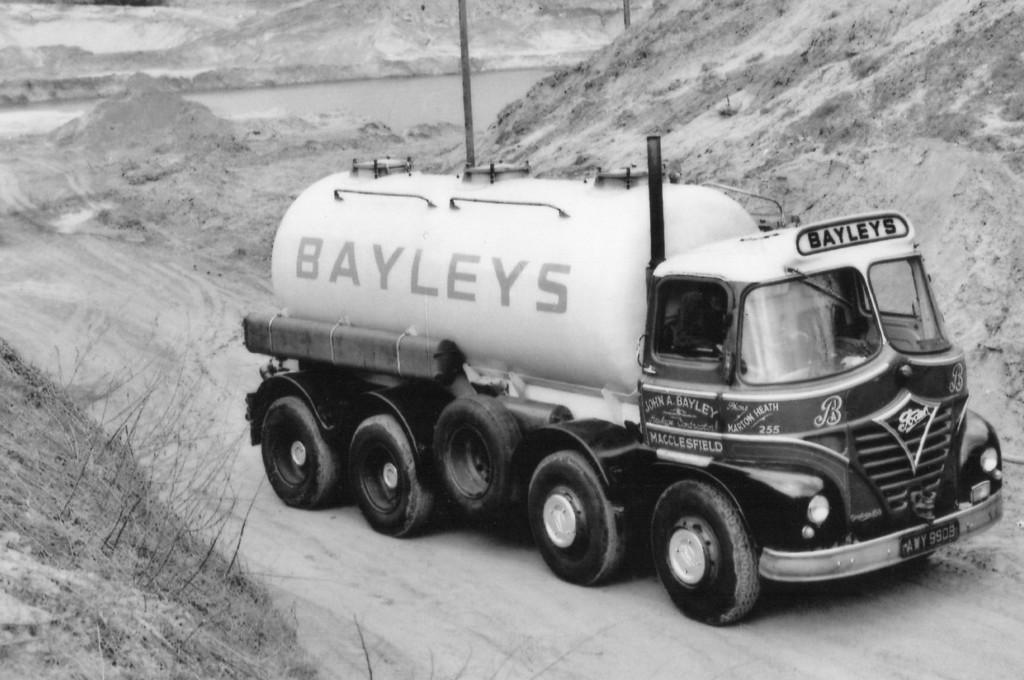What type of motor vehicle is in the image? The specific type of motor vehicle is not mentioned, but it is present in the image. Where is the motor vehicle located? The motor vehicle is on the road. What other objects can be seen in the image? There are wooden sticks and dried plants in the image. What type of paper is being used to cover the ground in the image? There is no paper present in the image, nor is there any indication that the ground is being covered. 